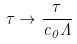<formula> <loc_0><loc_0><loc_500><loc_500>\tau \rightarrow \frac { \tau } { c _ { 0 } \Lambda }</formula> 